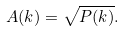Convert formula to latex. <formula><loc_0><loc_0><loc_500><loc_500>A ( k ) = \sqrt { P ( k ) } .</formula> 